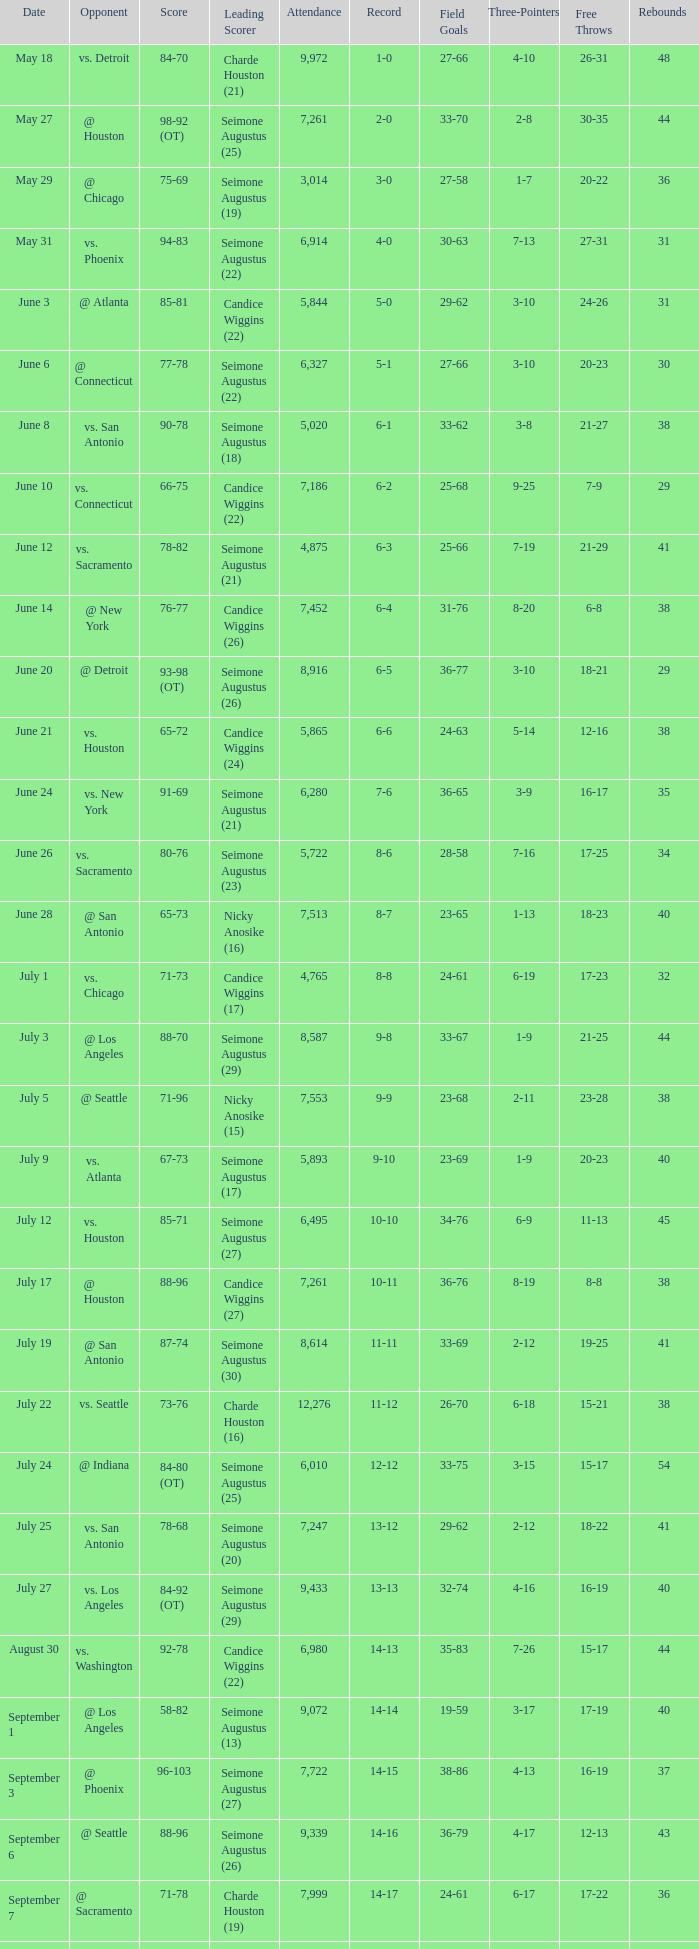Which Leading Scorer has an Opponent of @ seattle, and a Record of 14-16? Seimone Augustus (26). Parse the full table. {'header': ['Date', 'Opponent', 'Score', 'Leading Scorer', 'Attendance', 'Record', 'Field Goals', 'Three-Pointers', 'Free Throws', 'Rebounds '], 'rows': [['May 18', 'vs. Detroit', '84-70', 'Charde Houston (21)', '9,972', '1-0', '27-66', '4-10', '26-31', '48'], ['May 27', '@ Houston', '98-92 (OT)', 'Seimone Augustus (25)', '7,261', '2-0', '33-70', '2-8', '30-35', '44'], ['May 29', '@ Chicago', '75-69', 'Seimone Augustus (19)', '3,014', '3-0', '27-58', '1-7', '20-22', '36'], ['May 31', 'vs. Phoenix', '94-83', 'Seimone Augustus (22)', '6,914', '4-0', '30-63', '7-13', '27-31', '31'], ['June 3', '@ Atlanta', '85-81', 'Candice Wiggins (22)', '5,844', '5-0', '29-62', '3-10', '24-26', '31'], ['June 6', '@ Connecticut', '77-78', 'Seimone Augustus (22)', '6,327', '5-1', '27-66', '3-10', '20-23', '30'], ['June 8', 'vs. San Antonio', '90-78', 'Seimone Augustus (18)', '5,020', '6-1', '33-62', '3-8', '21-27', '38'], ['June 10', 'vs. Connecticut', '66-75', 'Candice Wiggins (22)', '7,186', '6-2', '25-68', '9-25', '7-9', '29'], ['June 12', 'vs. Sacramento', '78-82', 'Seimone Augustus (21)', '4,875', '6-3', '25-66', '7-19', '21-29', '41'], ['June 14', '@ New York', '76-77', 'Candice Wiggins (26)', '7,452', '6-4', '31-76', '8-20', '6-8', '38'], ['June 20', '@ Detroit', '93-98 (OT)', 'Seimone Augustus (26)', '8,916', '6-5', '36-77', '3-10', '18-21', '29'], ['June 21', 'vs. Houston', '65-72', 'Candice Wiggins (24)', '5,865', '6-6', '24-63', '5-14', '12-16', '38'], ['June 24', 'vs. New York', '91-69', 'Seimone Augustus (21)', '6,280', '7-6', '36-65', '3-9', '16-17', '35'], ['June 26', 'vs. Sacramento', '80-76', 'Seimone Augustus (23)', '5,722', '8-6', '28-58', '7-16', '17-25', '34'], ['June 28', '@ San Antonio', '65-73', 'Nicky Anosike (16)', '7,513', '8-7', '23-65', '1-13', '18-23', '40'], ['July 1', 'vs. Chicago', '71-73', 'Candice Wiggins (17)', '4,765', '8-8', '24-61', '6-19', '17-23', '32'], ['July 3', '@ Los Angeles', '88-70', 'Seimone Augustus (29)', '8,587', '9-8', '33-67', '1-9', '21-25', '44'], ['July 5', '@ Seattle', '71-96', 'Nicky Anosike (15)', '7,553', '9-9', '23-68', '2-11', '23-28', '38'], ['July 9', 'vs. Atlanta', '67-73', 'Seimone Augustus (17)', '5,893', '9-10', '23-69', '1-9', '20-23', '40'], ['July 12', 'vs. Houston', '85-71', 'Seimone Augustus (27)', '6,495', '10-10', '34-76', '6-9', '11-13', '45'], ['July 17', '@ Houston', '88-96', 'Candice Wiggins (27)', '7,261', '10-11', '36-76', '8-19', '8-8', '38'], ['July 19', '@ San Antonio', '87-74', 'Seimone Augustus (30)', '8,614', '11-11', '33-69', '2-12', '19-25', '41'], ['July 22', 'vs. Seattle', '73-76', 'Charde Houston (16)', '12,276', '11-12', '26-70', '6-18', '15-21', '38'], ['July 24', '@ Indiana', '84-80 (OT)', 'Seimone Augustus (25)', '6,010', '12-12', '33-75', '3-15', '15-17', '54'], ['July 25', 'vs. San Antonio', '78-68', 'Seimone Augustus (20)', '7,247', '13-12', '29-62', '2-12', '18-22', '41'], ['July 27', 'vs. Los Angeles', '84-92 (OT)', 'Seimone Augustus (29)', '9,433', '13-13', '32-74', '4-16', '16-19', '40'], ['August 30', 'vs. Washington', '92-78', 'Candice Wiggins (22)', '6,980', '14-13', '35-83', '7-26', '15-17', '44'], ['September 1', '@ Los Angeles', '58-82', 'Seimone Augustus (13)', '9,072', '14-14', '19-59', '3-17', '17-19', '40'], ['September 3', '@ Phoenix', '96-103', 'Seimone Augustus (27)', '7,722', '14-15', '38-86', '4-13', '16-19', '37'], ['September 6', '@ Seattle', '88-96', 'Seimone Augustus (26)', '9,339', '14-16', '36-79', '4-17', '12-13', '43'], ['September 7', '@ Sacramento', '71-78', 'Charde Houston (19)', '7,999', '14-17', '24-61', '6-17', '17-22', '36'], ['September 9', 'vs. Indiana', '86-76', 'Charde Houston (18)', '6,706', '15-17', '30-67', '3-21', '23-28', '47'], ['September 12', 'vs. Phoenix', '87-96', 'Lindsey Harding (20)', '8,343', '15-18', '33-71', '5-20', '16-24', '44'], ['September 14', '@ Washington', '96-70', 'Charde Houston (18)', '10,438', '16-18', '36-77', '3-11', '21-21', '44']]} 